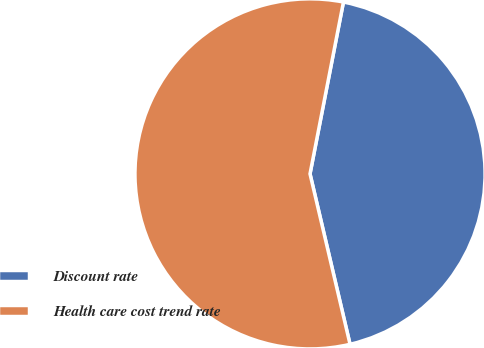Convert chart to OTSL. <chart><loc_0><loc_0><loc_500><loc_500><pie_chart><fcel>Discount rate<fcel>Health care cost trend rate<nl><fcel>43.27%<fcel>56.73%<nl></chart> 